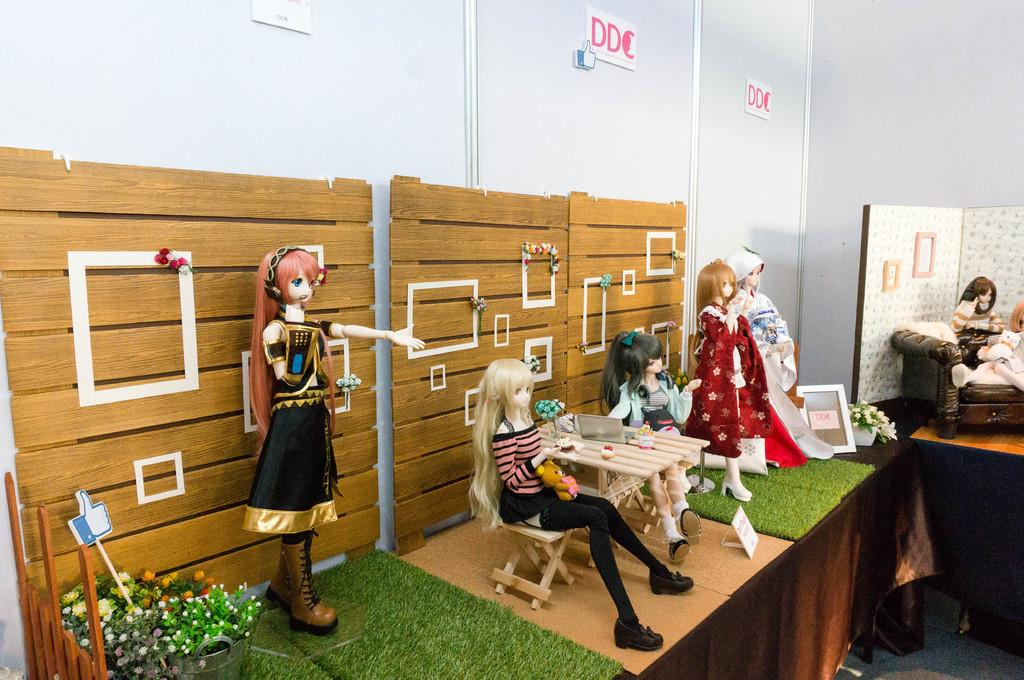How many dolls are present in the image? There are four dolls in the image. What can be seen in the background of the image? There are plants in the backdrop of the image. What type of material is used for the wall in the image? There is a wooden wall in the image. What type of notebook is being used by the dolls in the image? There is no notebook present in the image; it only features four dolls and a wooden wall with plants in the backdrop. 